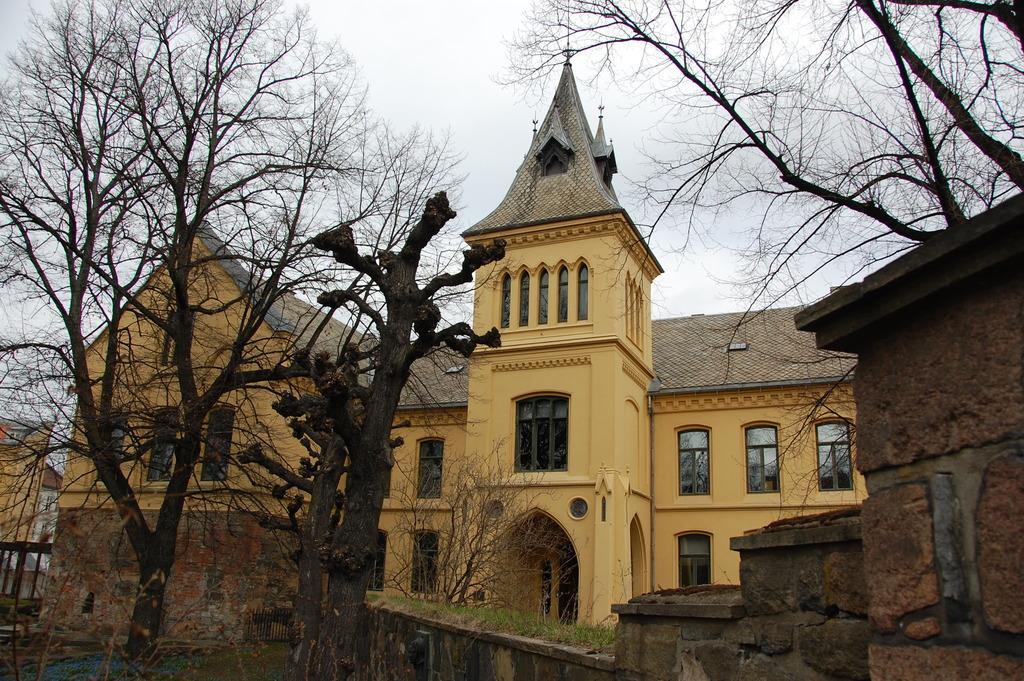Describe this image in one or two sentences. This picture is clicked outside. In the foreground we can see the small portion of grass and trees and we can see the buildings and the sky and some windows. 